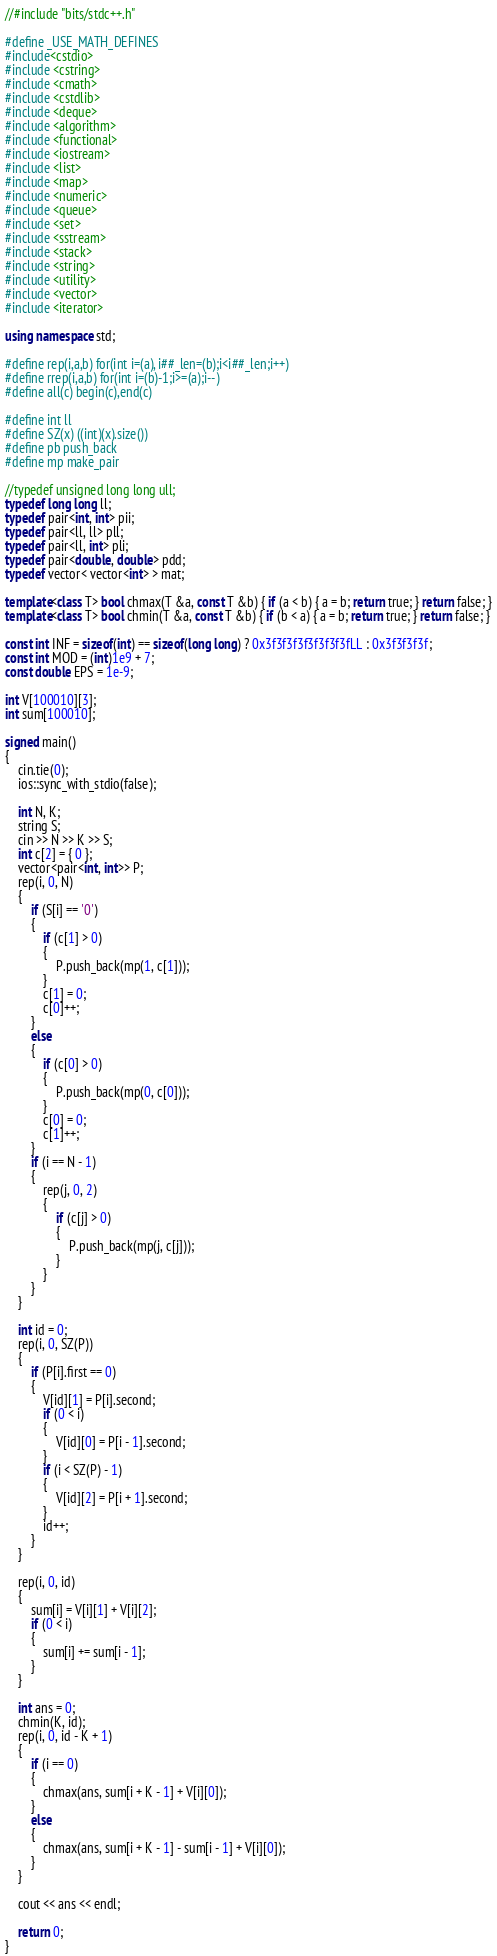Convert code to text. <code><loc_0><loc_0><loc_500><loc_500><_C++_>//#include "bits/stdc++.h"

#define _USE_MATH_DEFINES
#include<cstdio>
#include <cstring>
#include <cmath>
#include <cstdlib>
#include <deque>
#include <algorithm>
#include <functional>
#include <iostream>
#include <list>
#include <map>
#include <numeric>
#include <queue>
#include <set>
#include <sstream>
#include <stack>
#include <string>
#include <utility>
#include <vector>
#include <iterator>

using namespace std;

#define rep(i,a,b) for(int i=(a), i##_len=(b);i<i##_len;i++)
#define rrep(i,a,b) for(int i=(b)-1;i>=(a);i--)
#define all(c) begin(c),end(c)

#define int ll
#define SZ(x) ((int)(x).size())
#define pb push_back
#define mp make_pair

//typedef unsigned long long ull;
typedef long long ll;
typedef pair<int, int> pii;
typedef pair<ll, ll> pll;
typedef pair<ll, int> pli;
typedef pair<double, double> pdd;
typedef vector< vector<int> > mat;

template<class T> bool chmax(T &a, const T &b) { if (a < b) { a = b; return true; } return false; }
template<class T> bool chmin(T &a, const T &b) { if (b < a) { a = b; return true; } return false; }

const int INF = sizeof(int) == sizeof(long long) ? 0x3f3f3f3f3f3f3f3fLL : 0x3f3f3f3f;
const int MOD = (int)1e9 + 7;
const double EPS = 1e-9;

int V[100010][3];
int sum[100010];

signed main()
{
	cin.tie(0);
	ios::sync_with_stdio(false);

	int N, K;
	string S;
	cin >> N >> K >> S;
	int c[2] = { 0 };
	vector<pair<int, int>> P;
	rep(i, 0, N)
	{
		if (S[i] == '0')
		{
			if (c[1] > 0)
			{
				P.push_back(mp(1, c[1]));
			}
			c[1] = 0;
			c[0]++;
		}
		else
		{
			if (c[0] > 0)
			{
				P.push_back(mp(0, c[0]));
			}
			c[0] = 0;
			c[1]++;
		}
		if (i == N - 1)
		{
			rep(j, 0, 2)
			{
				if (c[j] > 0)
				{
					P.push_back(mp(j, c[j]));
				}
			}
		}
	}

	int id = 0;
	rep(i, 0, SZ(P))
	{
		if (P[i].first == 0)
		{
			V[id][1] = P[i].second;
			if (0 < i)
			{
				V[id][0] = P[i - 1].second;
			}
			if (i < SZ(P) - 1)
			{
				V[id][2] = P[i + 1].second;
			}
			id++;
		}
	}

	rep(i, 0, id)
	{
		sum[i] = V[i][1] + V[i][2];
		if (0 < i)
		{
			sum[i] += sum[i - 1];
		}
	}

	int ans = 0;
	chmin(K, id);
	rep(i, 0, id - K + 1)
	{
		if (i == 0)
		{
			chmax(ans, sum[i + K - 1] + V[i][0]);
		}
		else
		{
			chmax(ans, sum[i + K - 1] - sum[i - 1] + V[i][0]);
		}
	}

	cout << ans << endl;

	return 0;
}</code> 